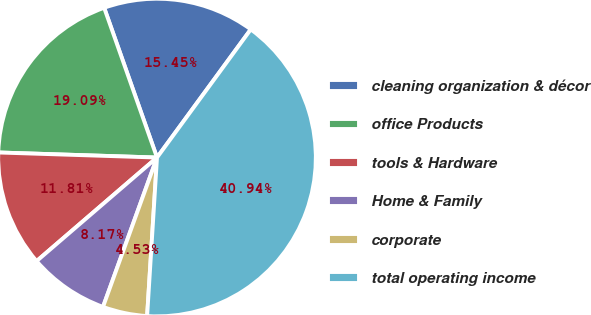Convert chart. <chart><loc_0><loc_0><loc_500><loc_500><pie_chart><fcel>cleaning organization & décor<fcel>office Products<fcel>tools & Hardware<fcel>Home & Family<fcel>corporate<fcel>total operating income<nl><fcel>15.45%<fcel>19.09%<fcel>11.81%<fcel>8.17%<fcel>4.53%<fcel>40.93%<nl></chart> 